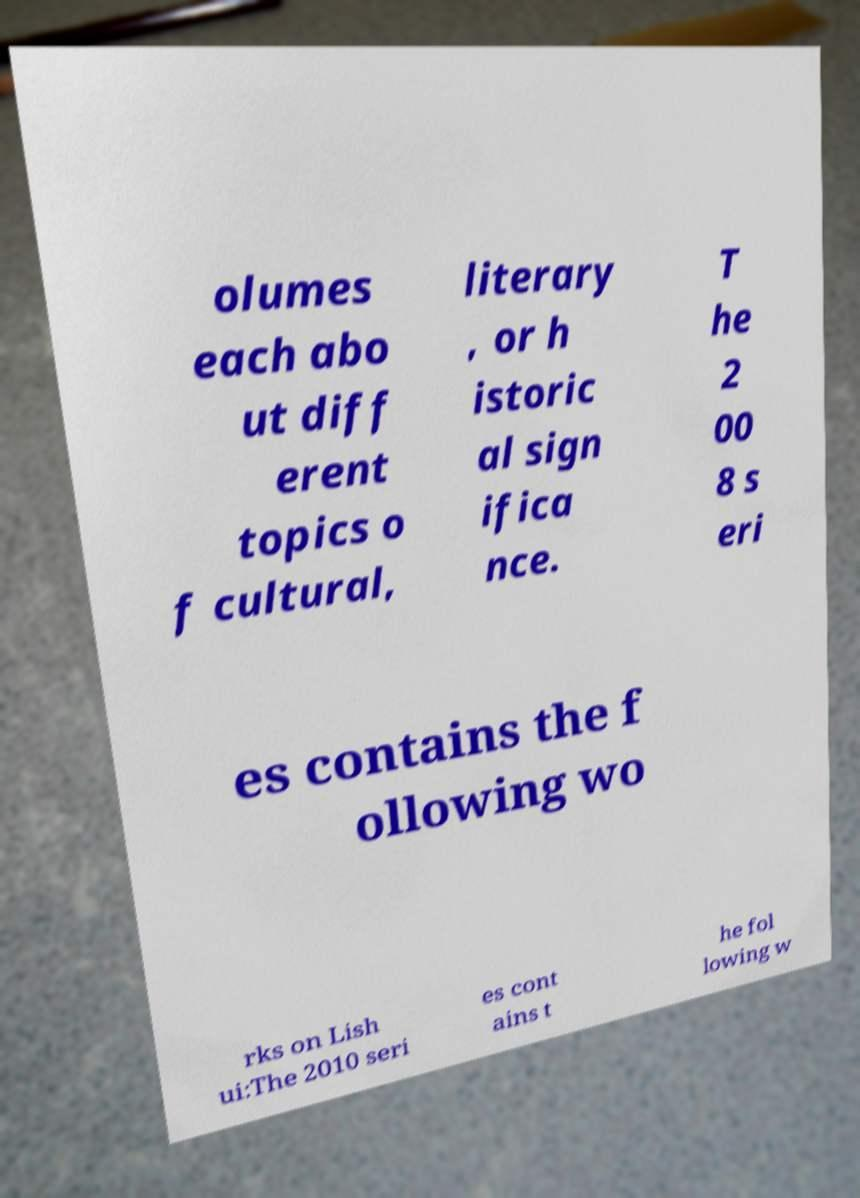What messages or text are displayed in this image? I need them in a readable, typed format. olumes each abo ut diff erent topics o f cultural, literary , or h istoric al sign ifica nce. T he 2 00 8 s eri es contains the f ollowing wo rks on Lish ui:The 2010 seri es cont ains t he fol lowing w 